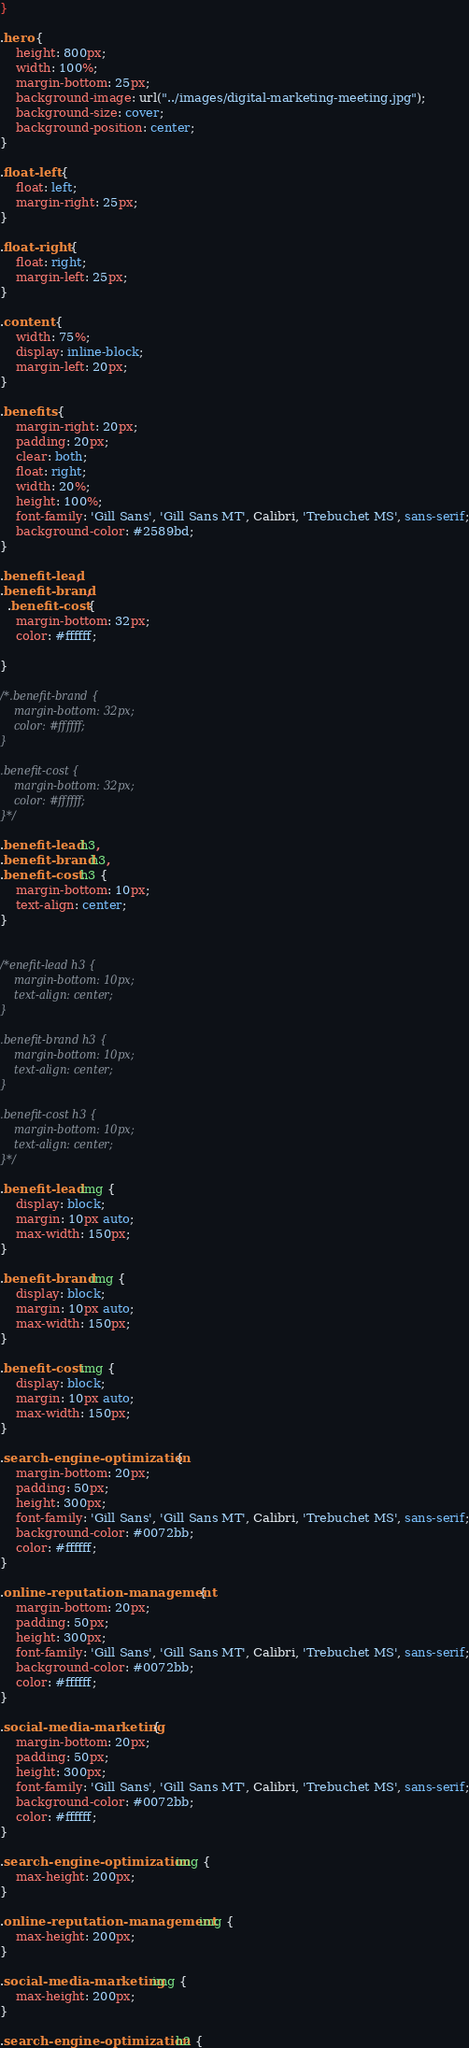<code> <loc_0><loc_0><loc_500><loc_500><_CSS_>}

.hero {
    height: 800px;
    width: 100%;
    margin-bottom: 25px;
    background-image: url("../images/digital-marketing-meeting.jpg");
    background-size: cover;
    background-position: center;
}

.float-left {
    float: left;
    margin-right: 25px;
}

.float-right {
    float: right;
    margin-left: 25px;
}

.content {
    width: 75%;
    display: inline-block;
    margin-left: 20px;
}

.benefits {
    margin-right: 20px;
    padding: 20px;
    clear: both;
    float: right;
    width: 20%;
    height: 100%;
    font-family: 'Gill Sans', 'Gill Sans MT', Calibri, 'Trebuchet MS', sans-serif;
    background-color: #2589bd;
}

.benefit-lead, 
.benefit-brand,   
  .benefit-cost {
    margin-bottom: 32px;
    color: #ffffff;
   
}

/*.benefit-brand {
    margin-bottom: 32px;
    color: #ffffff;
}

.benefit-cost {
    margin-bottom: 32px;
    color: #ffffff;
}*/

.benefit-lead h3,
.benefit-brand h3,
.benefit-cost h3 {
    margin-bottom: 10px;
    text-align: center;  
}


/*enefit-lead h3 {
    margin-bottom: 10px;
    text-align: center;
}

.benefit-brand h3 {
    margin-bottom: 10px;
    text-align: center;
}

.benefit-cost h3 {
    margin-bottom: 10px;
    text-align: center;
}*/

.benefit-lead img {
    display: block;
    margin: 10px auto;
    max-width: 150px;
}

.benefit-brand img {
    display: block;
    margin: 10px auto;
    max-width: 150px;
}

.benefit-cost img {
    display: block;
    margin: 10px auto;
    max-width: 150px;
}

.search-engine-optimization {
    margin-bottom: 20px;
    padding: 50px;
    height: 300px;
    font-family: 'Gill Sans', 'Gill Sans MT', Calibri, 'Trebuchet MS', sans-serif;
    background-color: #0072bb;
    color: #ffffff;
}

.online-reputation-management {
    margin-bottom: 20px;
    padding: 50px;
    height: 300px;
    font-family: 'Gill Sans', 'Gill Sans MT', Calibri, 'Trebuchet MS', sans-serif;
    background-color: #0072bb;
    color: #ffffff;
}

.social-media-marketing {
    margin-bottom: 20px;
    padding: 50px;
    height: 300px;
    font-family: 'Gill Sans', 'Gill Sans MT', Calibri, 'Trebuchet MS', sans-serif;
    background-color: #0072bb;
    color: #ffffff;
}

.search-engine-optimization img {
    max-height: 200px;
}

.online-reputation-management img {
    max-height: 200px;
}

.social-media-marketing img {
    max-height: 200px;
}

.search-engine-optimization h2 {</code> 